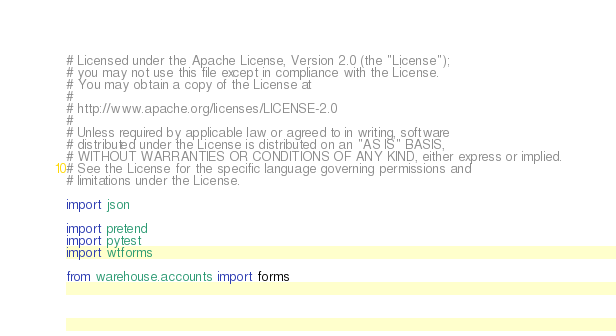Convert code to text. <code><loc_0><loc_0><loc_500><loc_500><_Python_># Licensed under the Apache License, Version 2.0 (the "License");
# you may not use this file except in compliance with the License.
# You may obtain a copy of the License at
#
# http://www.apache.org/licenses/LICENSE-2.0
#
# Unless required by applicable law or agreed to in writing, software
# distributed under the License is distributed on an "AS IS" BASIS,
# WITHOUT WARRANTIES OR CONDITIONS OF ANY KIND, either express or implied.
# See the License for the specific language governing permissions and
# limitations under the License.

import json

import pretend
import pytest
import wtforms

from warehouse.accounts import forms</code> 